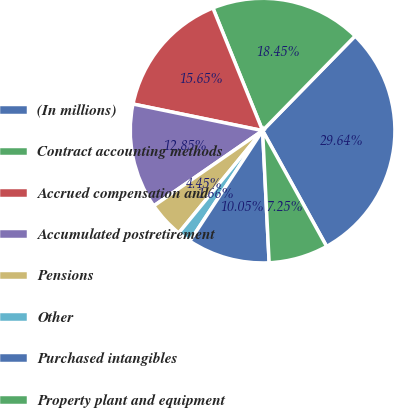Convert chart. <chart><loc_0><loc_0><loc_500><loc_500><pie_chart><fcel>(In millions)<fcel>Contract accounting methods<fcel>Accrued compensation and<fcel>Accumulated postretirement<fcel>Pensions<fcel>Other<fcel>Purchased intangibles<fcel>Property plant and equipment<nl><fcel>29.64%<fcel>18.45%<fcel>15.65%<fcel>12.85%<fcel>4.45%<fcel>1.66%<fcel>10.05%<fcel>7.25%<nl></chart> 